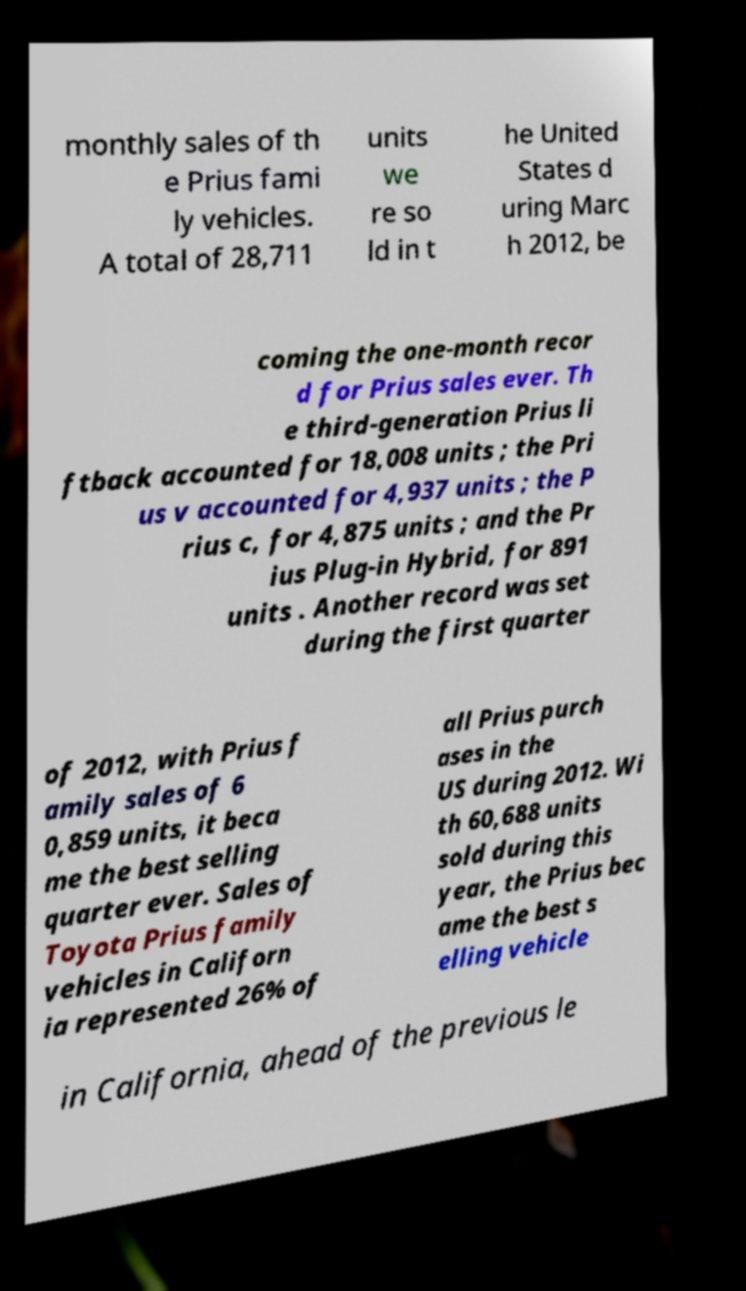I need the written content from this picture converted into text. Can you do that? monthly sales of th e Prius fami ly vehicles. A total of 28,711 units we re so ld in t he United States d uring Marc h 2012, be coming the one-month recor d for Prius sales ever. Th e third-generation Prius li ftback accounted for 18,008 units ; the Pri us v accounted for 4,937 units ; the P rius c, for 4,875 units ; and the Pr ius Plug-in Hybrid, for 891 units . Another record was set during the first quarter of 2012, with Prius f amily sales of 6 0,859 units, it beca me the best selling quarter ever. Sales of Toyota Prius family vehicles in Californ ia represented 26% of all Prius purch ases in the US during 2012. Wi th 60,688 units sold during this year, the Prius bec ame the best s elling vehicle in California, ahead of the previous le 